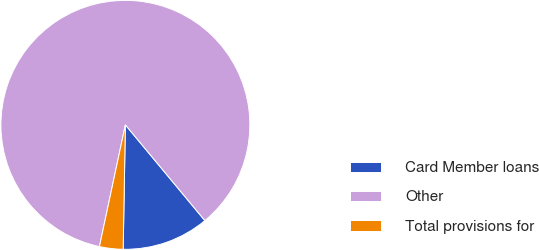Convert chart. <chart><loc_0><loc_0><loc_500><loc_500><pie_chart><fcel>Card Member loans<fcel>Other<fcel>Total provisions for<nl><fcel>11.31%<fcel>85.63%<fcel>3.06%<nl></chart> 